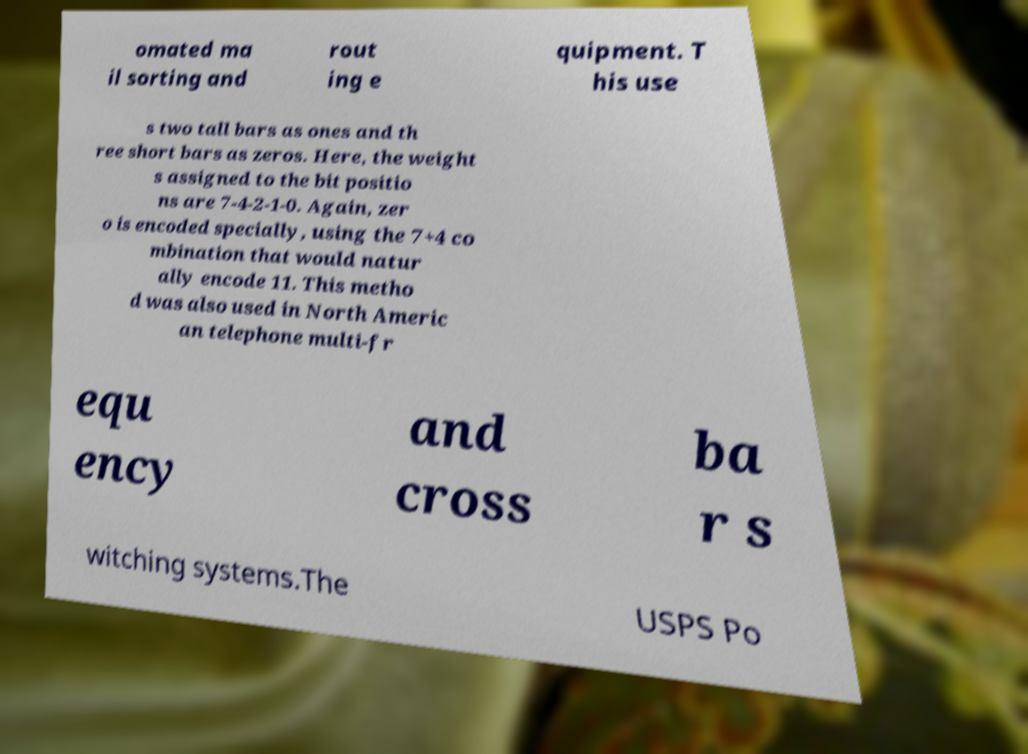There's text embedded in this image that I need extracted. Can you transcribe it verbatim? omated ma il sorting and rout ing e quipment. T his use s two tall bars as ones and th ree short bars as zeros. Here, the weight s assigned to the bit positio ns are 7-4-2-1-0. Again, zer o is encoded specially, using the 7+4 co mbination that would natur ally encode 11. This metho d was also used in North Americ an telephone multi-fr equ ency and cross ba r s witching systems.The USPS Po 